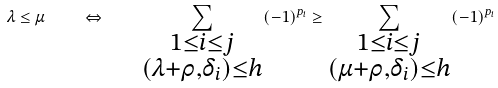<formula> <loc_0><loc_0><loc_500><loc_500>\lambda \leq \mu \quad \Leftrightarrow \quad \sum _ { \substack { 1 \leq i \leq j \\ ( \lambda + \rho , \delta _ { i } ) \leq h } } ( - 1 ) ^ { p _ { i } } \geq \sum _ { \substack { 1 \leq i \leq j \\ ( \mu + \rho , \delta _ { i } ) \leq h } } ( - 1 ) ^ { p _ { i } }</formula> 